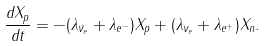<formula> <loc_0><loc_0><loc_500><loc_500>\frac { d X _ { p } } { d t } = - ( \lambda _ { \bar { \nu } _ { e } } + \lambda _ { e ^ { - } } ) X _ { p } + ( \lambda _ { \nu _ { e } } + \lambda _ { e ^ { + } } ) X _ { n } .</formula> 